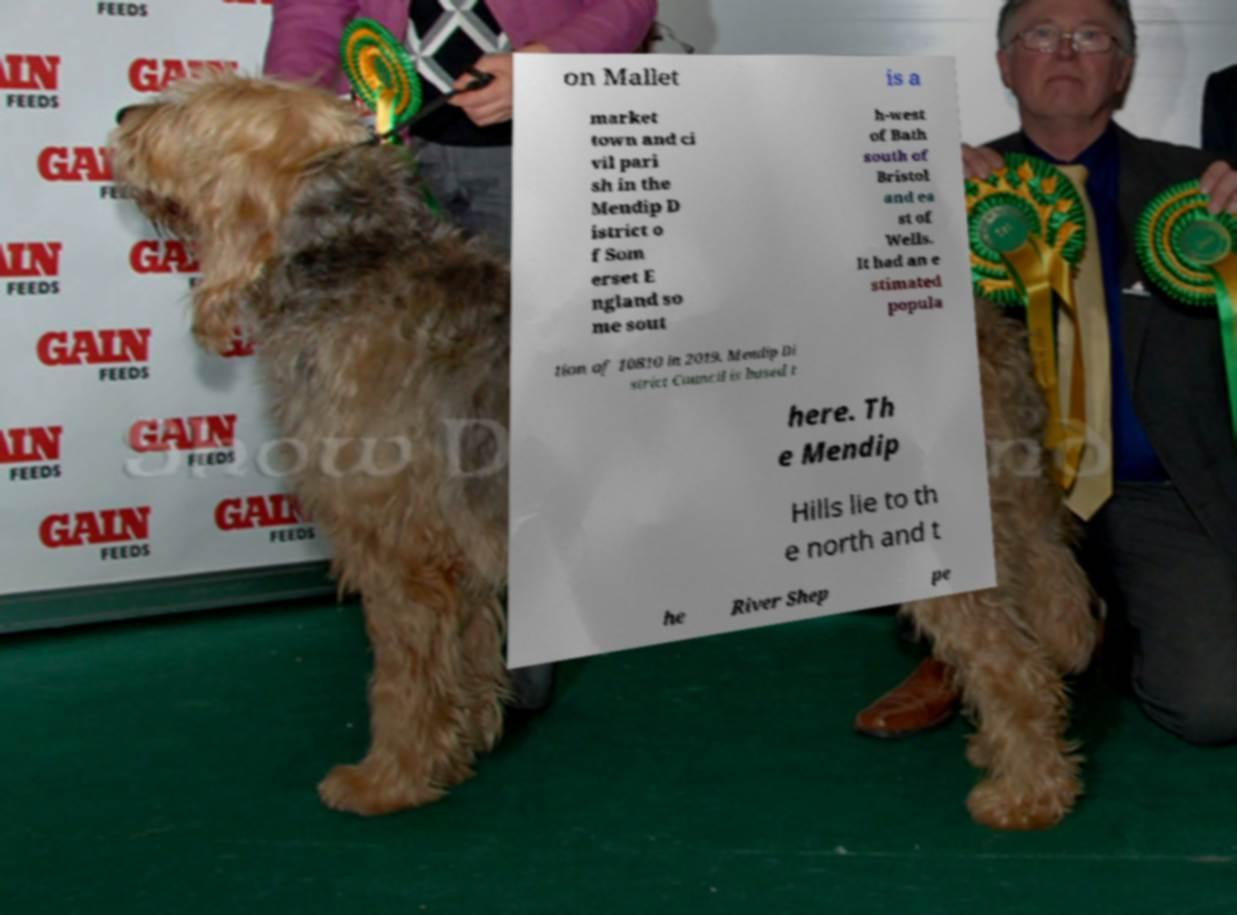What messages or text are displayed in this image? I need them in a readable, typed format. on Mallet is a market town and ci vil pari sh in the Mendip D istrict o f Som erset E ngland so me sout h-west of Bath south of Bristol and ea st of Wells. It had an e stimated popula tion of 10810 in 2019. Mendip Di strict Council is based t here. Th e Mendip Hills lie to th e north and t he River Shep pe 